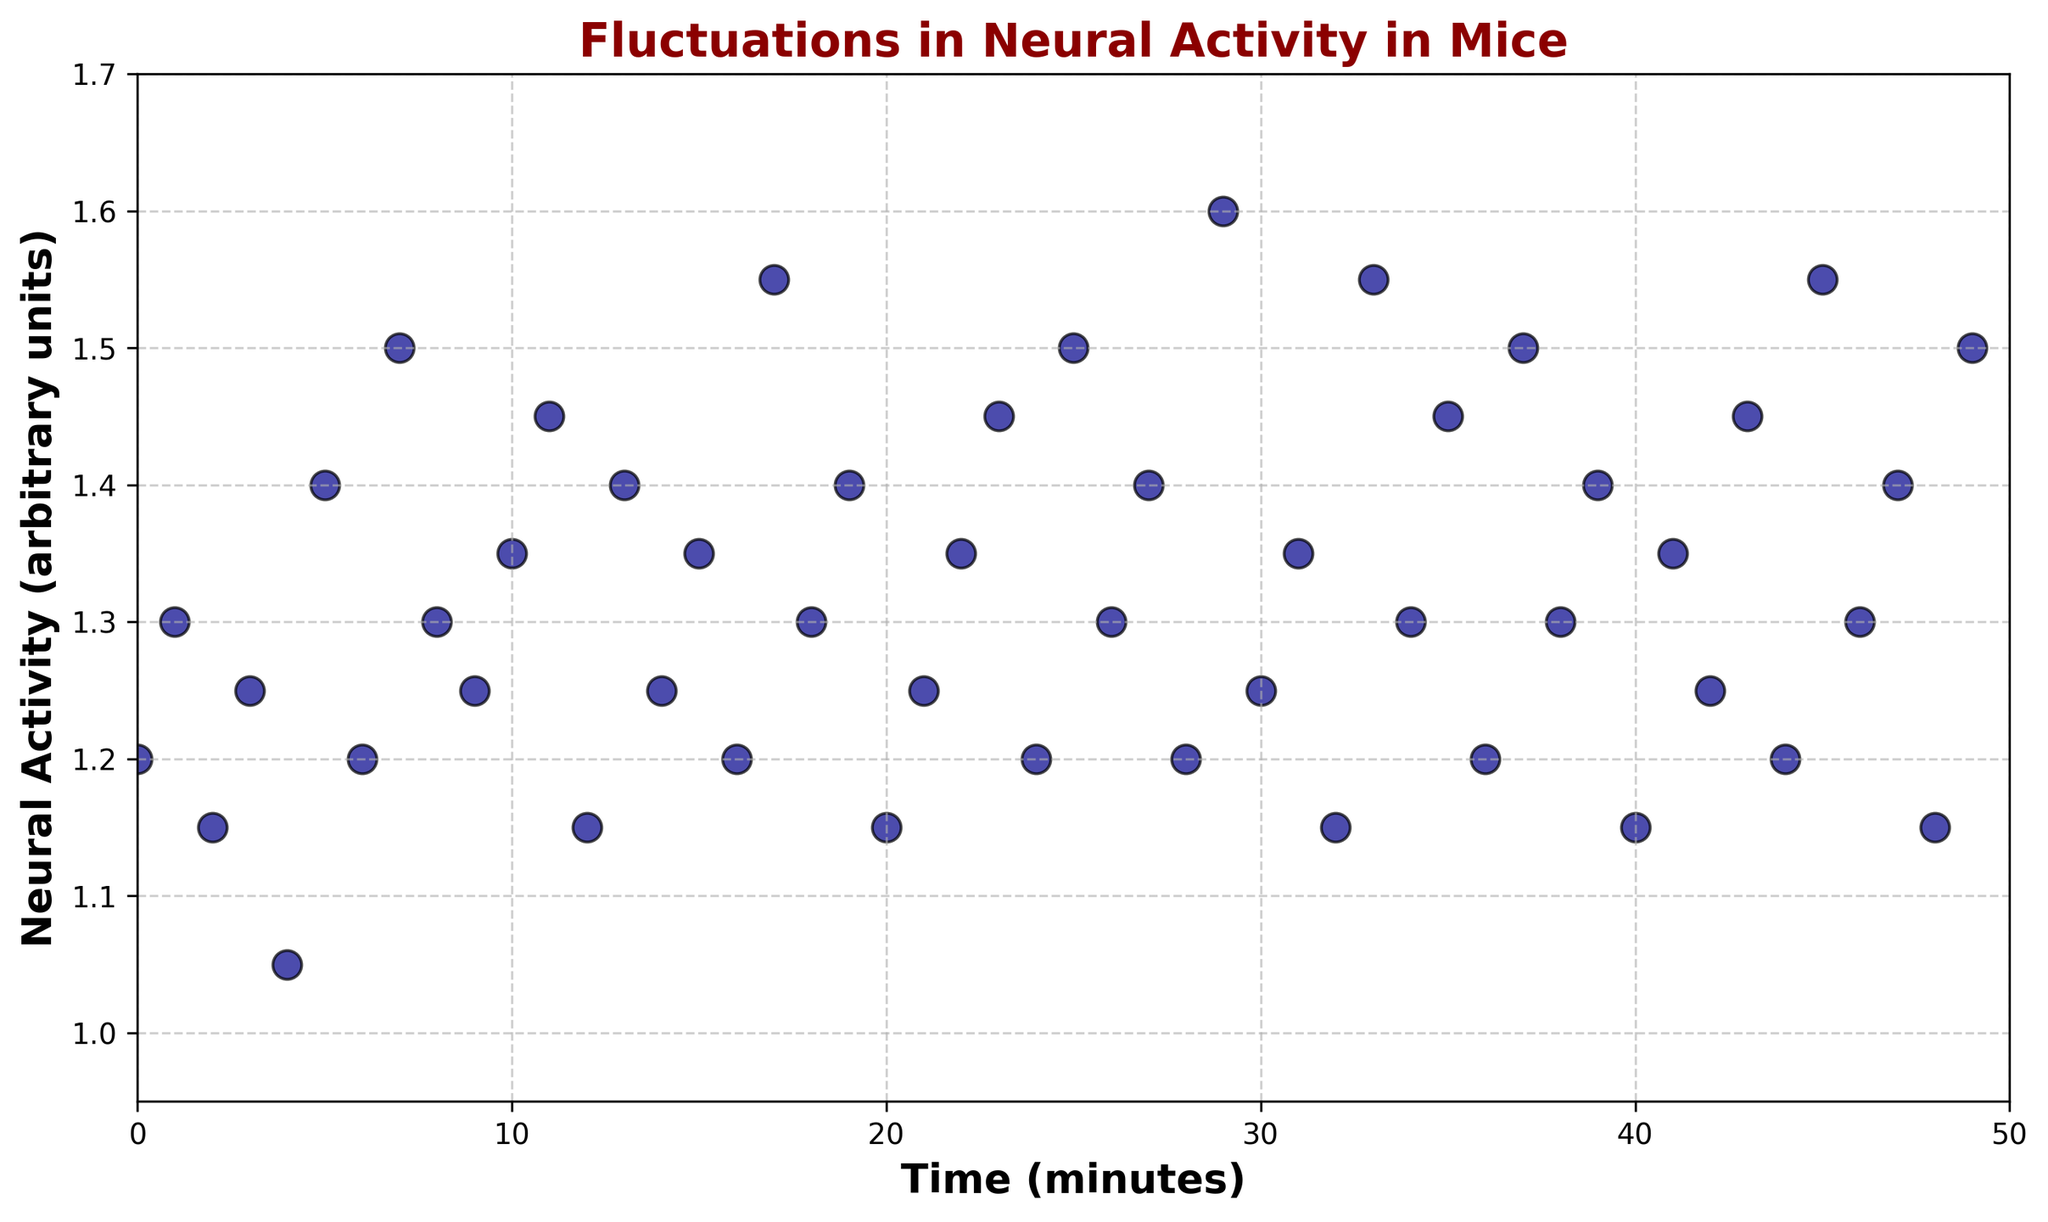When does Neural Activity peak? By inspecting the scatter plot, we identify the highest neural activity value on the y-axis. The activity peaks at 1.6 units at time 29 minutes.
Answer: 29 minutes What is the average neural activity level across the entire time span? Adding up all the neural activity values and dividing by the number of observations (50) will give us the average. Sum of activities is 63.05, so 63.05 / 50 = 1.261
Answer: 1.261 How many times does the neural activity hit the minimum value? The minimum value is 1.05, which occurs only once at time 4 in the scatter plot.
Answer: 1 time Between which two time points is the neural activity most stable with minimal fluctuations? Observing the plot visually, we notice that between time 21 and 28, the values seem to hover closely around 1.3 and 1.35 with little variation.
Answer: Time 21 to 28 Which time point exhibits the greatest increase in neural activity compared to the previous one? By comparing each pair of sequential points, we see the greatest increase happens from time 28 to time 29 where it jumps from 1.2 to 1.6 units.
Answer: Between time 28 and 29 Does neural activity show any noticeable trend over the entire time span? From visual inspection, the values seem to vary around an average value without showing a strong increasing or decreasing trend overall.
Answer: No noticeable trend What is the difference between the maximum and minimum neural activity values recorded? The maximum value is 1.6 and the minimum is 1.05, so their difference is 1.6 - 1.05 = 0.55.
Answer: 0.55 Which time interval experiences the greatest drop in neural activity? The largest drop is observed visually between time 1 (1.3) and time 2 (1.15), which is a decrease of 0.15 units.
Answer: Between time 1 and 2 At how many distinct time points is the neural activity above 1.4 units? Checking each point, we see that the activity exceeds 1.4 units at 7, 17, 23, 25, 29, 33, 35, 37, 43, and 45, totaling 10 distinct times.
Answer: 10 times What is the median neural activity value observed? Ordering the values, the middle value (or average of the two middle values) in a dataset of 50 points is positioned at the 25th and 26th value. From the ordered list it is the average of 1.3 and 1.3, so the median is (1.3 + 1.3) / 2 = 1.3.
Answer: 1.3 